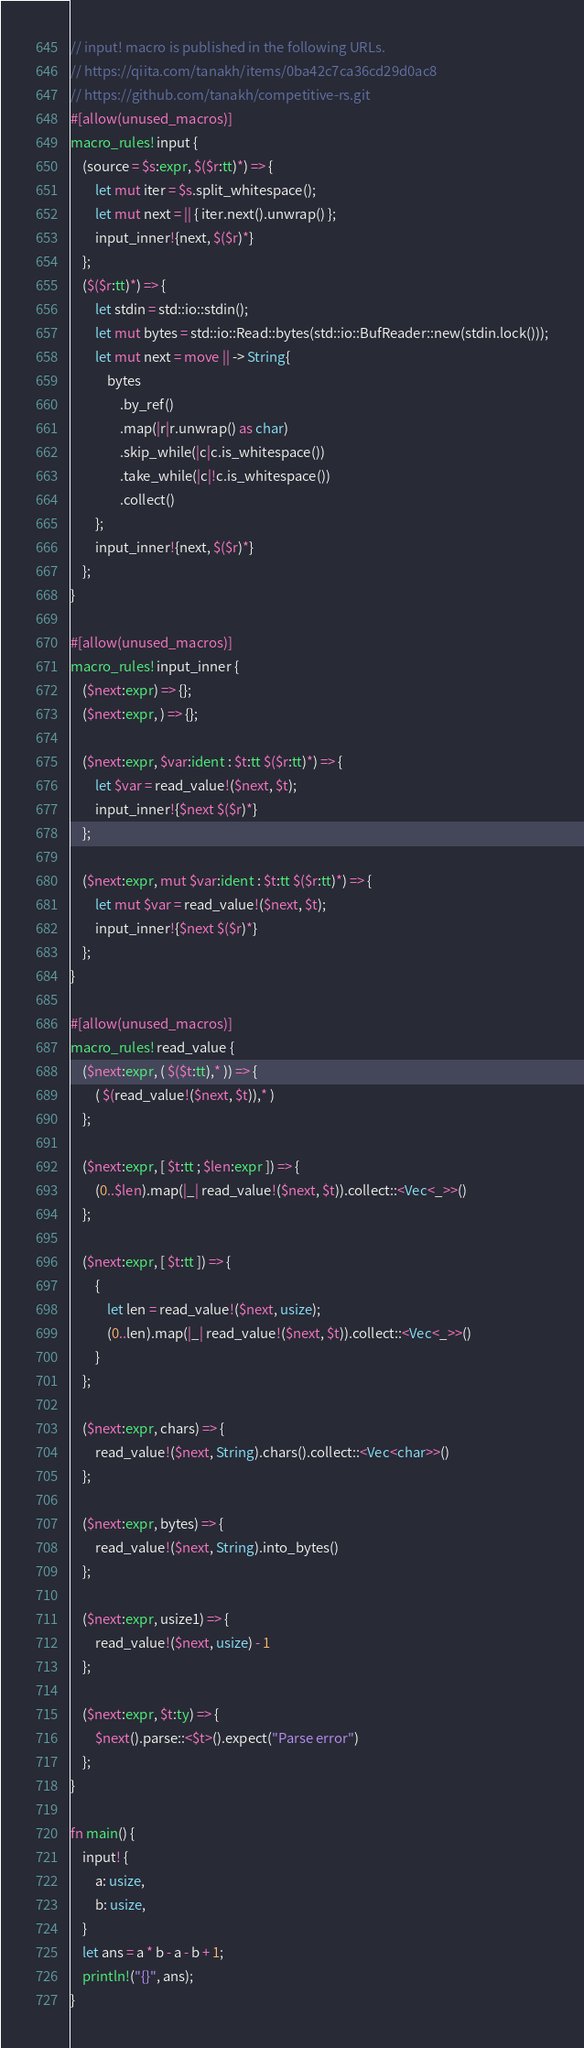<code> <loc_0><loc_0><loc_500><loc_500><_Rust_>// input! macro is published in the following URLs.
// https://qiita.com/tanakh/items/0ba42c7ca36cd29d0ac8
// https://github.com/tanakh/competitive-rs.git
#[allow(unused_macros)]
macro_rules! input {
    (source = $s:expr, $($r:tt)*) => {
        let mut iter = $s.split_whitespace();
        let mut next = || { iter.next().unwrap() };
        input_inner!{next, $($r)*}
    };
    ($($r:tt)*) => {
        let stdin = std::io::stdin();
        let mut bytes = std::io::Read::bytes(std::io::BufReader::new(stdin.lock()));
        let mut next = move || -> String{
            bytes
                .by_ref()
                .map(|r|r.unwrap() as char)
                .skip_while(|c|c.is_whitespace())
                .take_while(|c|!c.is_whitespace())
                .collect()
        };
        input_inner!{next, $($r)*}
    };
}

#[allow(unused_macros)]
macro_rules! input_inner {
    ($next:expr) => {};
    ($next:expr, ) => {};

    ($next:expr, $var:ident : $t:tt $($r:tt)*) => {
        let $var = read_value!($next, $t);
        input_inner!{$next $($r)*}
    };

    ($next:expr, mut $var:ident : $t:tt $($r:tt)*) => {
        let mut $var = read_value!($next, $t);
        input_inner!{$next $($r)*}
    };
}

#[allow(unused_macros)]
macro_rules! read_value {
    ($next:expr, ( $($t:tt),* )) => {
        ( $(read_value!($next, $t)),* )
    };

    ($next:expr, [ $t:tt ; $len:expr ]) => {
        (0..$len).map(|_| read_value!($next, $t)).collect::<Vec<_>>()
    };

    ($next:expr, [ $t:tt ]) => {
        {
            let len = read_value!($next, usize);
            (0..len).map(|_| read_value!($next, $t)).collect::<Vec<_>>()
        }
    };

    ($next:expr, chars) => {
        read_value!($next, String).chars().collect::<Vec<char>>()
    };

    ($next:expr, bytes) => {
        read_value!($next, String).into_bytes()
    };

    ($next:expr, usize1) => {
        read_value!($next, usize) - 1
    };

    ($next:expr, $t:ty) => {
        $next().parse::<$t>().expect("Parse error")
    };
}

fn main() {
    input! {
        a: usize,
        b: usize,
    }
    let ans = a * b - a - b + 1;
    println!("{}", ans);
}
</code> 